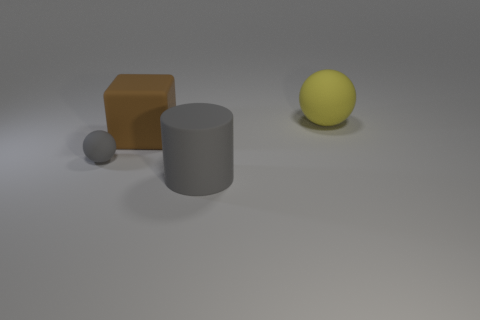There is another object that is the same color as the small matte thing; what material is it?
Ensure brevity in your answer.  Rubber. There is a rubber ball that is in front of the big object behind the large brown rubber block; what number of small matte objects are behind it?
Your answer should be compact. 0. What number of blue objects are either large blocks or metallic spheres?
Provide a short and direct response. 0. The small object that is made of the same material as the brown cube is what color?
Give a very brief answer. Gray. Is there anything else that has the same size as the cube?
Make the answer very short. Yes. What number of tiny objects are gray matte cylinders or green shiny blocks?
Keep it short and to the point. 0. Are there fewer brown matte things than big blue metallic things?
Ensure brevity in your answer.  No. What is the color of the large rubber thing that is the same shape as the tiny gray object?
Provide a succinct answer. Yellow. Is there any other thing that is the same shape as the big yellow rubber thing?
Offer a terse response. Yes. Is the number of large blocks greater than the number of purple things?
Your answer should be compact. Yes. 